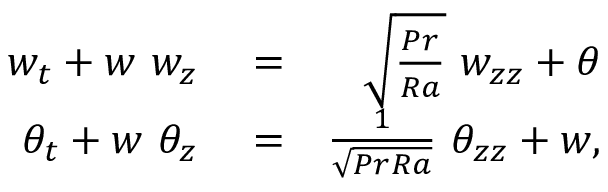<formula> <loc_0><loc_0><loc_500><loc_500>\begin{array} { r l r } { w _ { t } + w \ w _ { z } } & = } & { \sqrt { \frac { P r } { R a } } \ w _ { z z } + \theta } \\ { \theta _ { t } + w \ \theta _ { z } } & = } & { \frac { 1 } { \sqrt { P r R a } } \ \theta _ { z z } + w , } \end{array}</formula> 